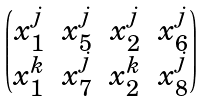<formula> <loc_0><loc_0><loc_500><loc_500>\begin{pmatrix} x _ { 1 } ^ { j } & x _ { 5 } ^ { j } & x _ { 2 } ^ { j } & x _ { 6 } ^ { j } \\ x _ { 1 } ^ { k } & x _ { 7 } ^ { j } & x _ { 2 } ^ { k } & x _ { 8 } ^ { j } \end{pmatrix}</formula> 